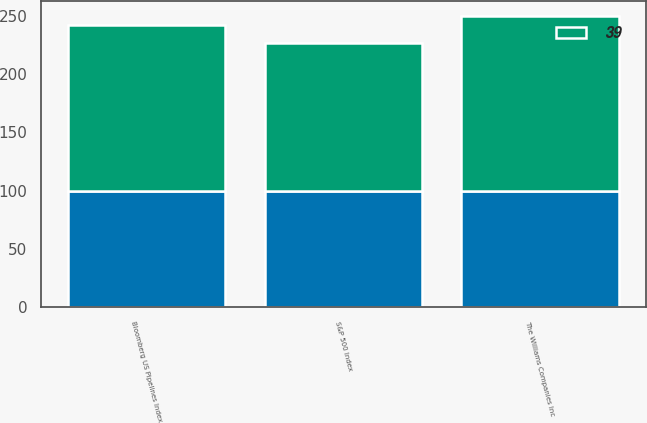<chart> <loc_0><loc_0><loc_500><loc_500><stacked_bar_chart><ecel><fcel>The Williams Companies Inc<fcel>S&P 500 Index<fcel>Bloomberg US Pipelines Index<nl><fcel>nan<fcel>100<fcel>100<fcel>100<nl><fcel>39<fcel>149.8<fcel>126.5<fcel>141.7<nl></chart> 